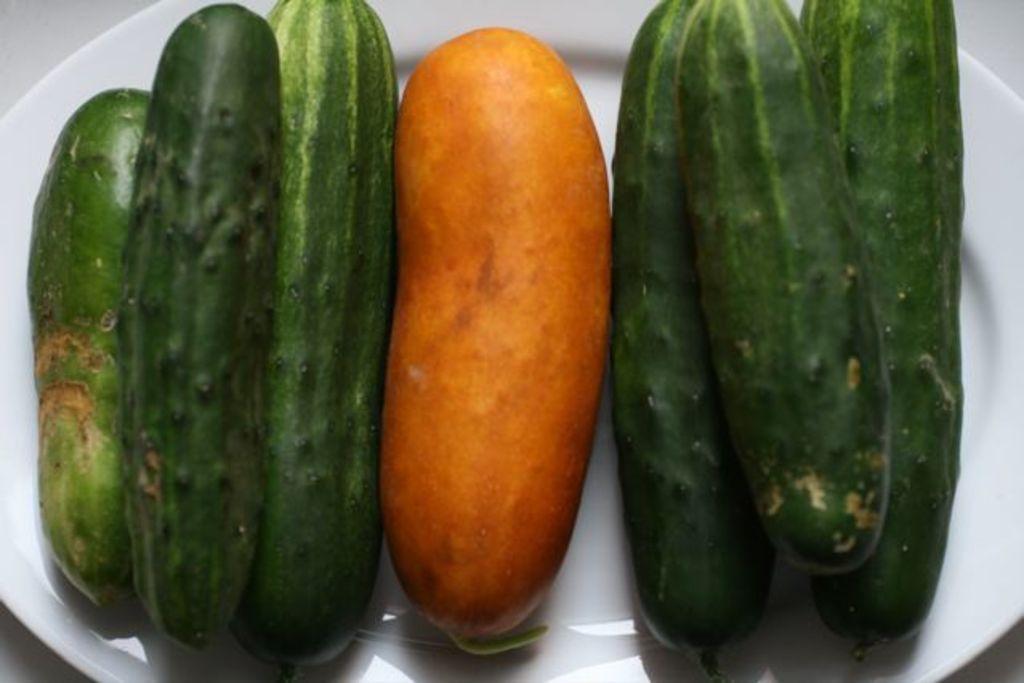Describe this image in one or two sentences. Here in this picture we can see cucumbers present on a plate, which is present on the table. 